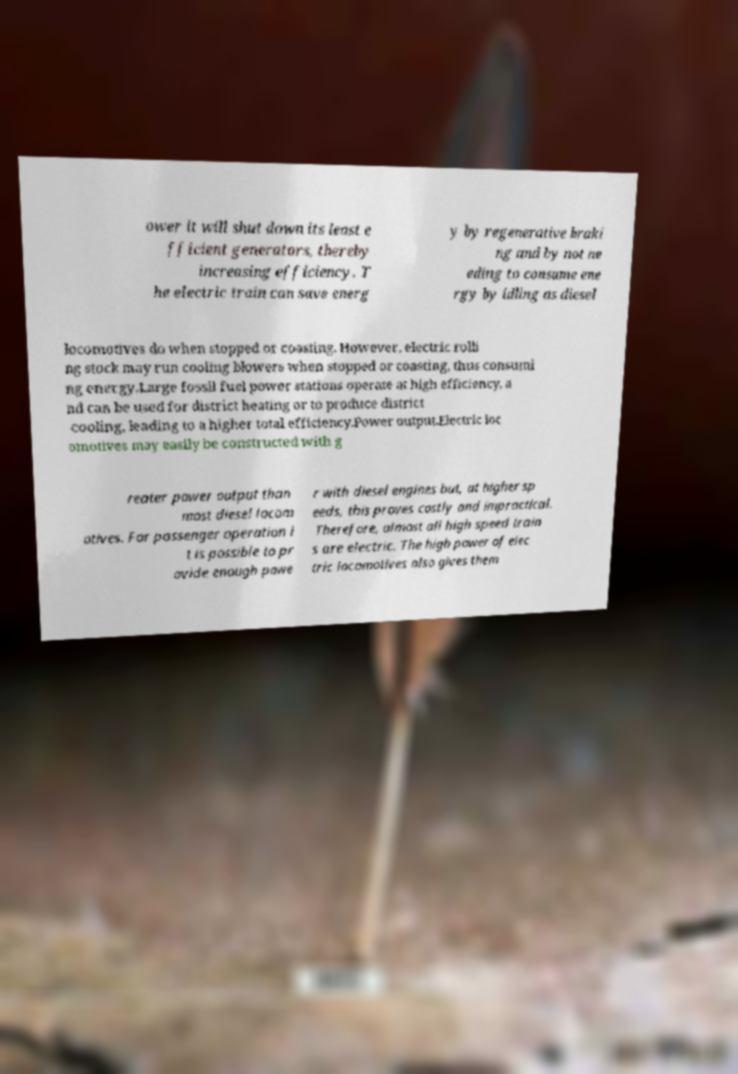For documentation purposes, I need the text within this image transcribed. Could you provide that? ower it will shut down its least e fficient generators, thereby increasing efficiency. T he electric train can save energ y by regenerative braki ng and by not ne eding to consume ene rgy by idling as diesel locomotives do when stopped or coasting. However, electric rolli ng stock may run cooling blowers when stopped or coasting, thus consumi ng energy.Large fossil fuel power stations operate at high efficiency, a nd can be used for district heating or to produce district cooling, leading to a higher total efficiency.Power output.Electric loc omotives may easily be constructed with g reater power output than most diesel locom otives. For passenger operation i t is possible to pr ovide enough powe r with diesel engines but, at higher sp eeds, this proves costly and impractical. Therefore, almost all high speed train s are electric. The high power of elec tric locomotives also gives them 